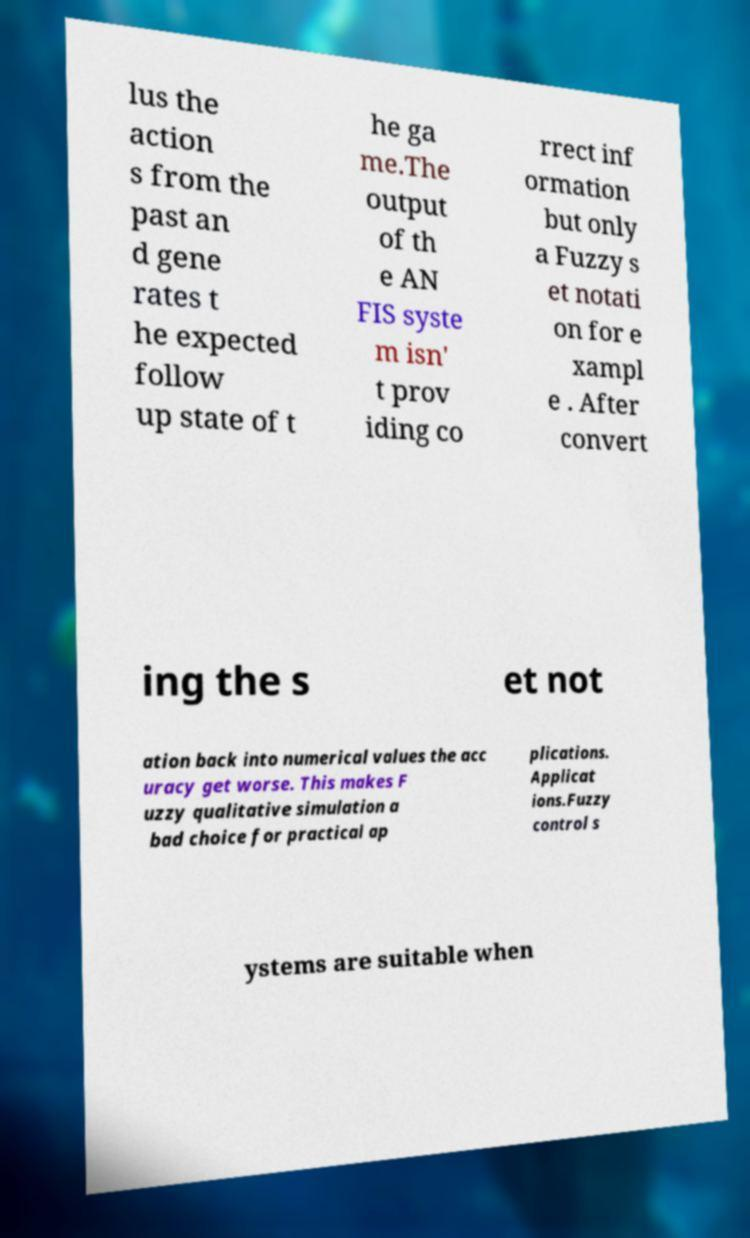Could you extract and type out the text from this image? lus the action s from the past an d gene rates t he expected follow up state of t he ga me.The output of th e AN FIS syste m isn' t prov iding co rrect inf ormation but only a Fuzzy s et notati on for e xampl e . After convert ing the s et not ation back into numerical values the acc uracy get worse. This makes F uzzy qualitative simulation a bad choice for practical ap plications. Applicat ions.Fuzzy control s ystems are suitable when 